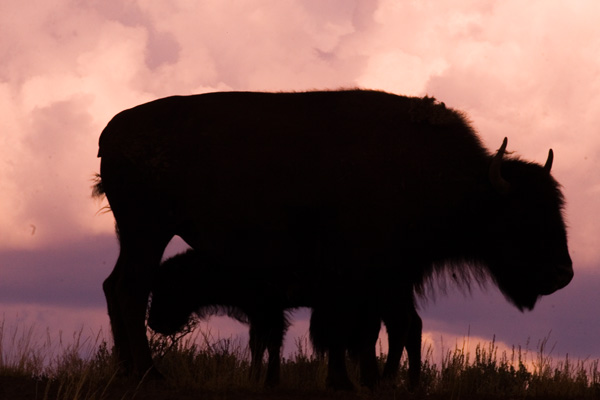What is the sharpness of this image? The image appears to have a moderate level of sharpness, with the silhouette of the animal clearly defined against the sky, although the finer details are not as crisp due to the lighting conditions. 